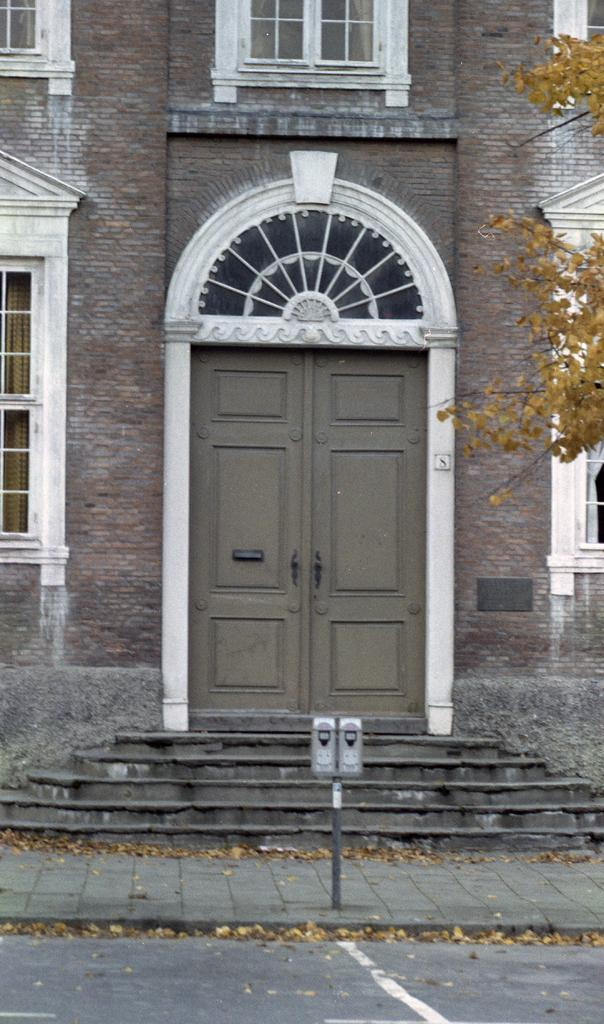What type of structure is present in the image? There is a building in the picture. What features can be observed on the building? The building has windows and doors. What other natural element is present in the image? There is a tree in the picture. Can you describe any other objects in the image? There are other objects in the picture, but their specific details are not mentioned in the provided facts. What type of smell can be detected from the building in the image? There is no information about smells in the image, so it cannot be determined from the picture. 